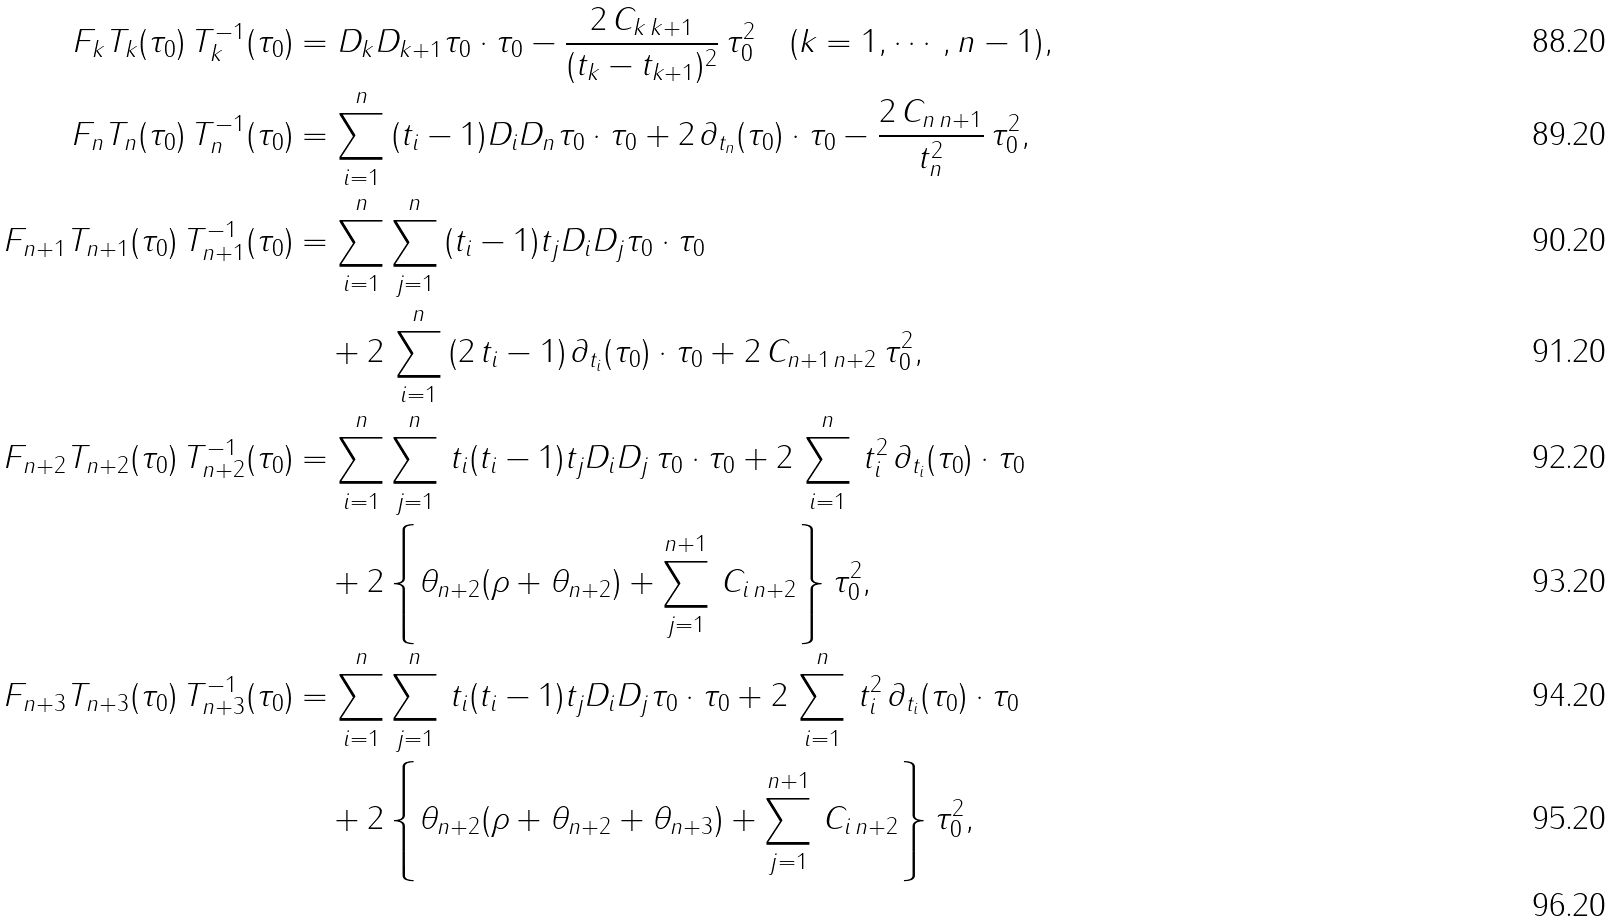Convert formula to latex. <formula><loc_0><loc_0><loc_500><loc_500>F _ { k } T _ { k } ( \tau _ { 0 } ) \, T _ { k } ^ { - 1 } ( \tau _ { 0 } ) & = D _ { k } D _ { k + 1 } \tau _ { 0 } \cdot \tau _ { 0 } - \frac { 2 \, C _ { k \, k + 1 } } { ( t _ { k } - t _ { k + 1 } ) ^ { 2 } } \, \tau _ { 0 } ^ { 2 } \quad ( k = 1 , \cdots , n - 1 ) , \\ F _ { n } T _ { n } ( \tau _ { 0 } ) \, T _ { n } ^ { - 1 } ( \tau _ { 0 } ) & = \sum _ { i = 1 } ^ { n } \, ( t _ { i } - 1 ) D _ { i } D _ { n } \tau _ { 0 } \cdot \tau _ { 0 } + 2 \, \partial _ { t _ { n } } ( \tau _ { 0 } ) \cdot \tau _ { 0 } - \frac { 2 \, C _ { n \, n + 1 } } { t _ { n } ^ { 2 } } \, \tau _ { 0 } ^ { 2 } , \\ F _ { n + 1 } T _ { n + 1 } ( \tau _ { 0 } ) \, T _ { n + 1 } ^ { - 1 } ( \tau _ { 0 } ) & = \sum _ { i = 1 } ^ { n } \sum _ { j = 1 } ^ { n } \, ( t _ { i } - 1 ) t _ { j } D _ { i } D _ { j } \tau _ { 0 } \cdot \tau _ { 0 } \\ & \quad + 2 \, \sum _ { i = 1 } ^ { n } \, ( 2 \, t _ { i } - 1 ) \, \partial _ { t _ { i } } ( \tau _ { 0 } ) \cdot \tau _ { 0 } + 2 \, C _ { n + 1 \, n + 2 } \, \tau _ { 0 } ^ { 2 } , \\ F _ { n + 2 } T _ { n + 2 } ( \tau _ { 0 } ) \, T _ { n + 2 } ^ { - 1 } ( \tau _ { 0 } ) & = \sum _ { i = 1 } ^ { n } \sum _ { j = 1 } ^ { n } \, t _ { i } ( t _ { i } - 1 ) t _ { j } D _ { i } D _ { j } \, \tau _ { 0 } \cdot \tau _ { 0 } + 2 \, \sum _ { i = 1 } ^ { n } \, t _ { i } ^ { 2 } \, \partial _ { t _ { i } } ( \tau _ { 0 } ) \cdot \tau _ { 0 } \\ & \quad + 2 \left \{ \theta _ { n + 2 } ( \rho + \theta _ { n + 2 } ) + \sum _ { j = 1 } ^ { n + 1 } \, C _ { i \, n + 2 } \right \} \tau _ { 0 } ^ { 2 } , \\ F _ { n + 3 } T _ { n + 3 } ( \tau _ { 0 } ) \, T _ { n + 3 } ^ { - 1 } ( \tau _ { 0 } ) & = \sum _ { i = 1 } ^ { n } \sum _ { j = 1 } ^ { n } \, t _ { i } ( t _ { i } - 1 ) t _ { j } D _ { i } D _ { j } \tau _ { 0 } \cdot \tau _ { 0 } + 2 \, \sum _ { i = 1 } ^ { n } \, t _ { i } ^ { 2 } \, \partial _ { t _ { i } } ( \tau _ { 0 } ) \cdot \tau _ { 0 } \\ & \quad + 2 \left \{ \theta _ { n + 2 } ( \rho + \theta _ { n + 2 } + \theta _ { n + 3 } ) + \sum _ { j = 1 } ^ { n + 1 } \, C _ { i \, n + 2 } \right \} \tau _ { 0 } ^ { 2 } , \\</formula> 